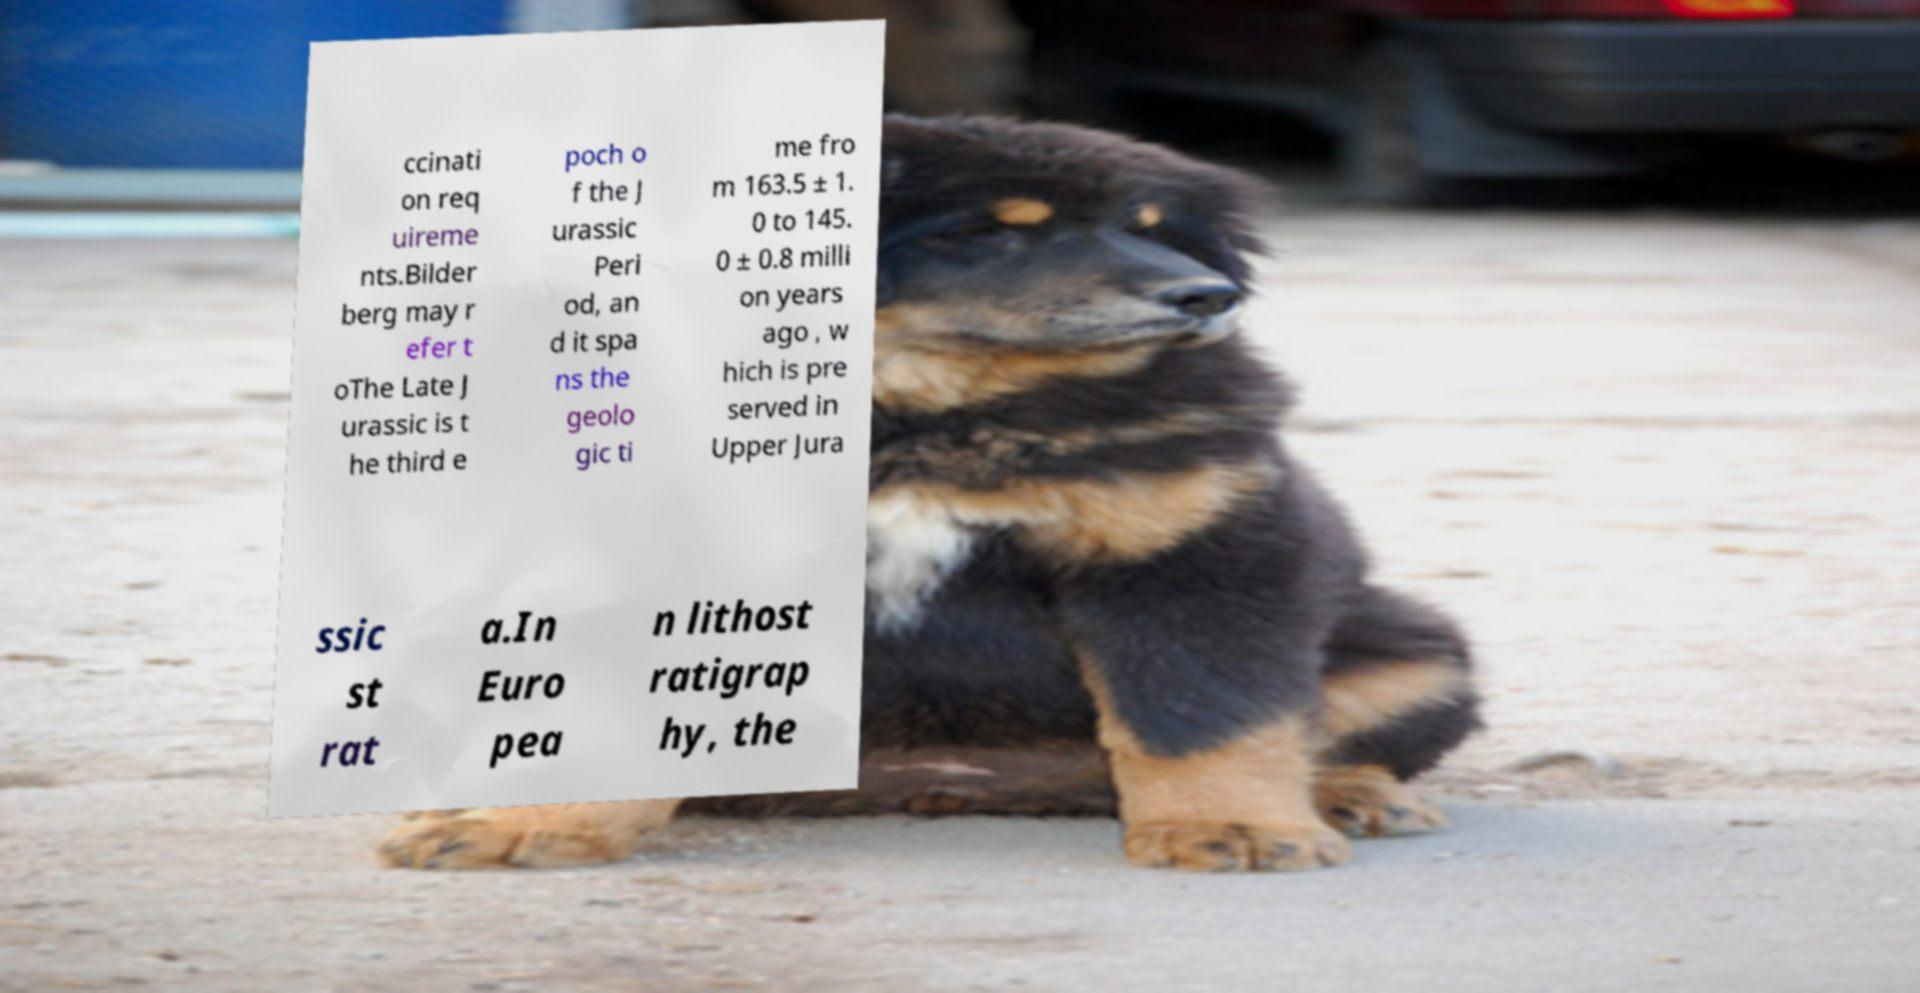Can you read and provide the text displayed in the image?This photo seems to have some interesting text. Can you extract and type it out for me? ccinati on req uireme nts.Bilder berg may r efer t oThe Late J urassic is t he third e poch o f the J urassic Peri od, an d it spa ns the geolo gic ti me fro m 163.5 ± 1. 0 to 145. 0 ± 0.8 milli on years ago , w hich is pre served in Upper Jura ssic st rat a.In Euro pea n lithost ratigrap hy, the 